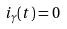Convert formula to latex. <formula><loc_0><loc_0><loc_500><loc_500>i _ { \gamma } ( t ) = 0</formula> 